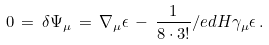<formula> <loc_0><loc_0><loc_500><loc_500>0 \, = \, \delta \Psi _ { \mu } \, = \, \nabla _ { \mu } \epsilon \, - \, \frac { 1 } { 8 \cdot 3 ! } \slash e d { H } \gamma _ { \mu } \epsilon \, .</formula> 